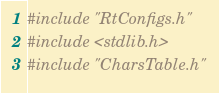<code> <loc_0><loc_0><loc_500><loc_500><_C_>#include "RtConfigs.h"
#include <stdlib.h>
#include "CharsTable.h"
</code> 